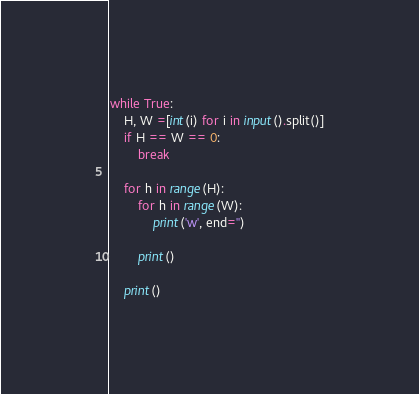<code> <loc_0><loc_0><loc_500><loc_500><_Python_>while True:
    H, W =[int(i) for i in input().split()]
    if H == W == 0:
        break

    for h in range(H):
        for h in range(W):
            print('w', end='')
        
        print()

    print()</code> 